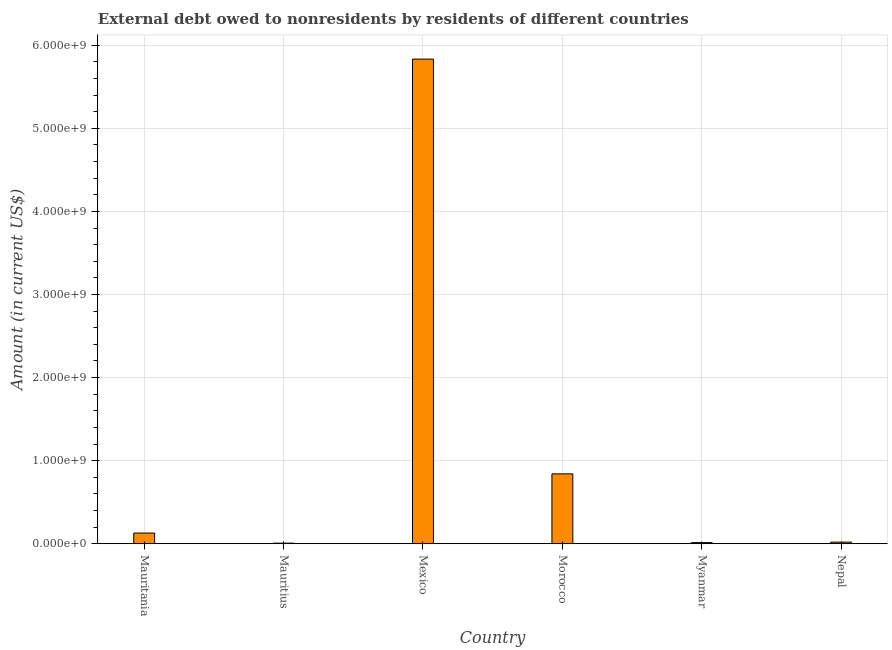Does the graph contain any zero values?
Offer a very short reply. No. What is the title of the graph?
Offer a very short reply. External debt owed to nonresidents by residents of different countries. What is the label or title of the X-axis?
Keep it short and to the point. Country. What is the label or title of the Y-axis?
Offer a terse response. Amount (in current US$). What is the debt in Myanmar?
Keep it short and to the point. 1.38e+07. Across all countries, what is the maximum debt?
Make the answer very short. 5.83e+09. Across all countries, what is the minimum debt?
Offer a terse response. 7.23e+06. In which country was the debt minimum?
Make the answer very short. Mauritius. What is the sum of the debt?
Your answer should be very brief. 6.84e+09. What is the difference between the debt in Mauritania and Mexico?
Make the answer very short. -5.70e+09. What is the average debt per country?
Make the answer very short. 1.14e+09. What is the median debt?
Provide a short and direct response. 7.40e+07. In how many countries, is the debt greater than 4400000000 US$?
Offer a very short reply. 1. What is the ratio of the debt in Mauritania to that in Nepal?
Your answer should be very brief. 6.63. Is the debt in Mauritius less than that in Nepal?
Offer a terse response. Yes. What is the difference between the highest and the second highest debt?
Provide a short and direct response. 4.99e+09. What is the difference between the highest and the lowest debt?
Provide a short and direct response. 5.83e+09. In how many countries, is the debt greater than the average debt taken over all countries?
Your answer should be very brief. 1. How many countries are there in the graph?
Your answer should be compact. 6. What is the Amount (in current US$) in Mauritania?
Keep it short and to the point. 1.29e+08. What is the Amount (in current US$) of Mauritius?
Provide a succinct answer. 7.23e+06. What is the Amount (in current US$) in Mexico?
Keep it short and to the point. 5.83e+09. What is the Amount (in current US$) of Morocco?
Make the answer very short. 8.41e+08. What is the Amount (in current US$) in Myanmar?
Provide a short and direct response. 1.38e+07. What is the Amount (in current US$) in Nepal?
Your answer should be compact. 1.94e+07. What is the difference between the Amount (in current US$) in Mauritania and Mauritius?
Offer a very short reply. 1.21e+08. What is the difference between the Amount (in current US$) in Mauritania and Mexico?
Your answer should be compact. -5.70e+09. What is the difference between the Amount (in current US$) in Mauritania and Morocco?
Make the answer very short. -7.12e+08. What is the difference between the Amount (in current US$) in Mauritania and Myanmar?
Provide a succinct answer. 1.15e+08. What is the difference between the Amount (in current US$) in Mauritania and Nepal?
Ensure brevity in your answer.  1.09e+08. What is the difference between the Amount (in current US$) in Mauritius and Mexico?
Your answer should be compact. -5.83e+09. What is the difference between the Amount (in current US$) in Mauritius and Morocco?
Provide a succinct answer. -8.34e+08. What is the difference between the Amount (in current US$) in Mauritius and Myanmar?
Ensure brevity in your answer.  -6.55e+06. What is the difference between the Amount (in current US$) in Mauritius and Nepal?
Offer a terse response. -1.22e+07. What is the difference between the Amount (in current US$) in Mexico and Morocco?
Keep it short and to the point. 4.99e+09. What is the difference between the Amount (in current US$) in Mexico and Myanmar?
Your answer should be very brief. 5.82e+09. What is the difference between the Amount (in current US$) in Mexico and Nepal?
Ensure brevity in your answer.  5.81e+09. What is the difference between the Amount (in current US$) in Morocco and Myanmar?
Give a very brief answer. 8.27e+08. What is the difference between the Amount (in current US$) in Morocco and Nepal?
Your response must be concise. 8.22e+08. What is the difference between the Amount (in current US$) in Myanmar and Nepal?
Provide a succinct answer. -5.61e+06. What is the ratio of the Amount (in current US$) in Mauritania to that in Mauritius?
Provide a succinct answer. 17.79. What is the ratio of the Amount (in current US$) in Mauritania to that in Mexico?
Make the answer very short. 0.02. What is the ratio of the Amount (in current US$) in Mauritania to that in Morocco?
Your answer should be compact. 0.15. What is the ratio of the Amount (in current US$) in Mauritania to that in Myanmar?
Offer a very short reply. 9.33. What is the ratio of the Amount (in current US$) in Mauritania to that in Nepal?
Provide a short and direct response. 6.63. What is the ratio of the Amount (in current US$) in Mauritius to that in Mexico?
Offer a very short reply. 0. What is the ratio of the Amount (in current US$) in Mauritius to that in Morocco?
Make the answer very short. 0.01. What is the ratio of the Amount (in current US$) in Mauritius to that in Myanmar?
Your answer should be very brief. 0.53. What is the ratio of the Amount (in current US$) in Mauritius to that in Nepal?
Offer a very short reply. 0.37. What is the ratio of the Amount (in current US$) in Mexico to that in Morocco?
Provide a short and direct response. 6.93. What is the ratio of the Amount (in current US$) in Mexico to that in Myanmar?
Provide a short and direct response. 423.41. What is the ratio of the Amount (in current US$) in Mexico to that in Nepal?
Make the answer very short. 300.9. What is the ratio of the Amount (in current US$) in Morocco to that in Myanmar?
Offer a very short reply. 61.05. What is the ratio of the Amount (in current US$) in Morocco to that in Nepal?
Ensure brevity in your answer.  43.39. What is the ratio of the Amount (in current US$) in Myanmar to that in Nepal?
Provide a short and direct response. 0.71. 